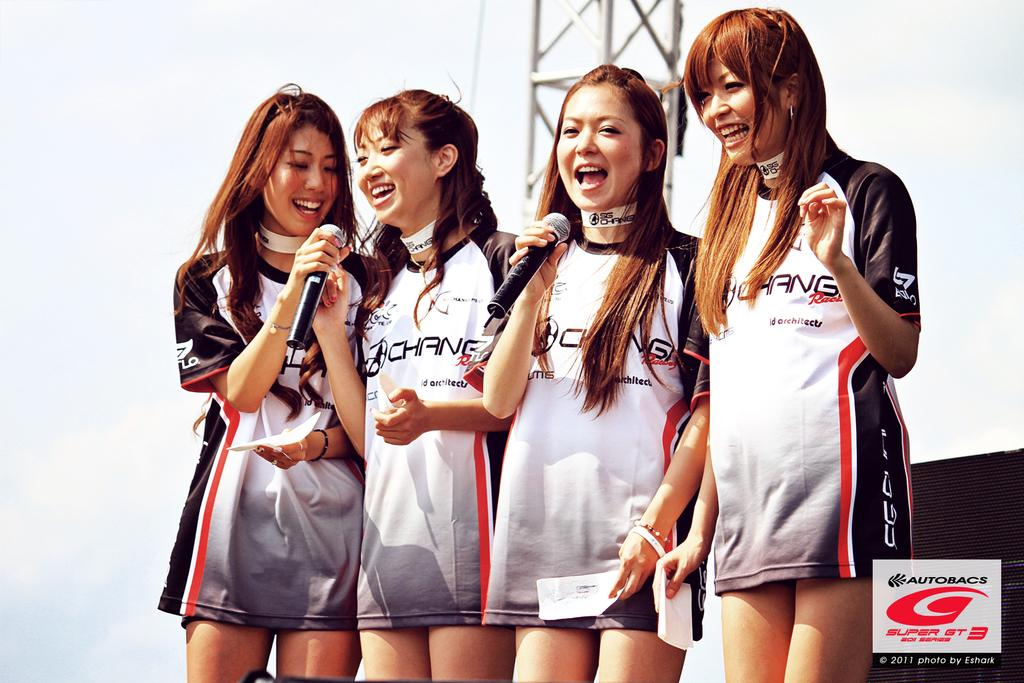<image>
Summarize the visual content of the image. A group of 4 girls wearing Autobacs branded T-shirts 